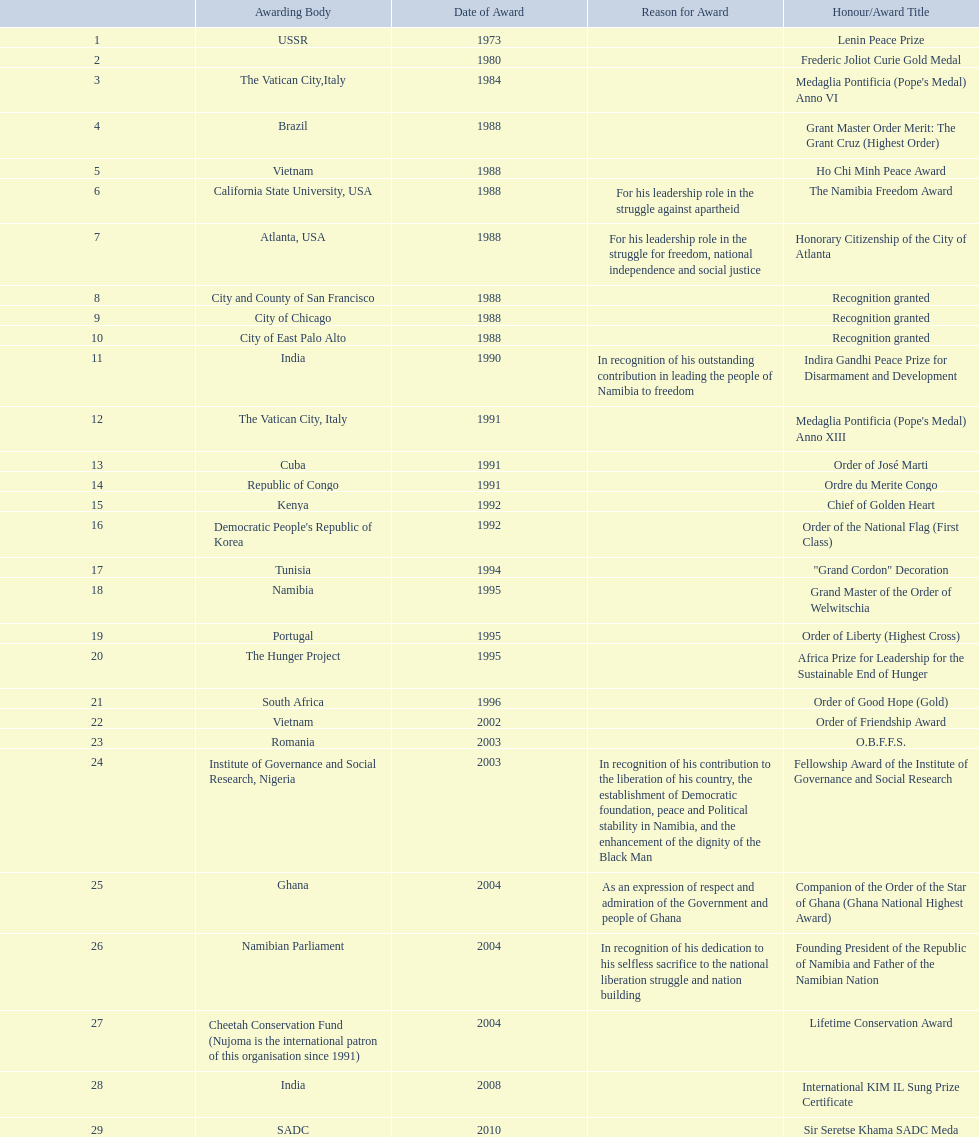What awards did sam nujoma win? 1, 1973, Lenin Peace Prize, Frederic Joliot Curie Gold Medal, Medaglia Pontificia (Pope's Medal) Anno VI, Grant Master Order Merit: The Grant Cruz (Highest Order), Ho Chi Minh Peace Award, The Namibia Freedom Award, Honorary Citizenship of the City of Atlanta, Recognition granted, Recognition granted, Recognition granted, Indira Gandhi Peace Prize for Disarmament and Development, Medaglia Pontificia (Pope's Medal) Anno XIII, Order of José Marti, Ordre du Merite Congo, Chief of Golden Heart, Order of the National Flag (First Class), "Grand Cordon" Decoration, Grand Master of the Order of Welwitschia, Order of Liberty (Highest Cross), Africa Prize for Leadership for the Sustainable End of Hunger, Order of Good Hope (Gold), Order of Friendship Award, O.B.F.F.S., Fellowship Award of the Institute of Governance and Social Research, Companion of the Order of the Star of Ghana (Ghana National Highest Award), Founding President of the Republic of Namibia and Father of the Namibian Nation, Lifetime Conservation Award, International KIM IL Sung Prize Certificate, Sir Seretse Khama SADC Meda. Who was the awarding body for the o.b.f.f.s award? Romania. 